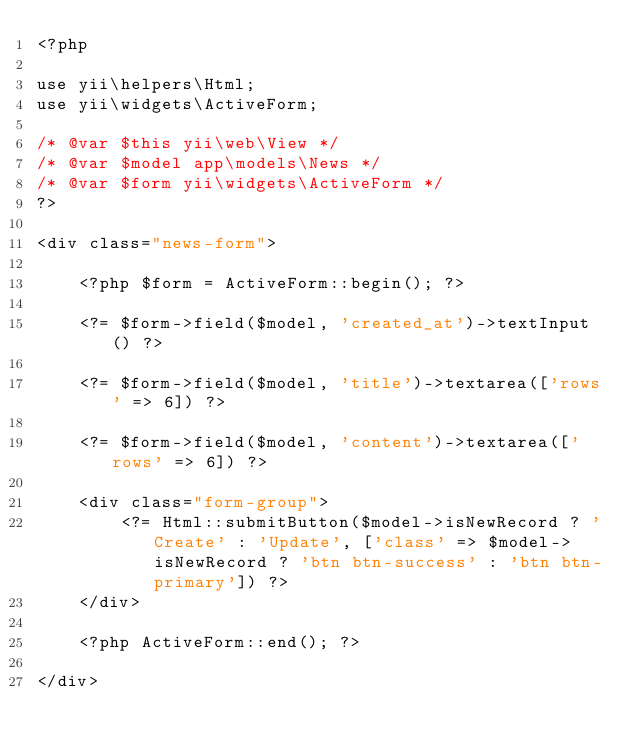<code> <loc_0><loc_0><loc_500><loc_500><_PHP_><?php

use yii\helpers\Html;
use yii\widgets\ActiveForm;

/* @var $this yii\web\View */
/* @var $model app\models\News */
/* @var $form yii\widgets\ActiveForm */
?>

<div class="news-form">

    <?php $form = ActiveForm::begin(); ?>

    <?= $form->field($model, 'created_at')->textInput() ?>

    <?= $form->field($model, 'title')->textarea(['rows' => 6]) ?>

    <?= $form->field($model, 'content')->textarea(['rows' => 6]) ?>

    <div class="form-group">
        <?= Html::submitButton($model->isNewRecord ? 'Create' : 'Update', ['class' => $model->isNewRecord ? 'btn btn-success' : 'btn btn-primary']) ?>
    </div>

    <?php ActiveForm::end(); ?>

</div>
</code> 